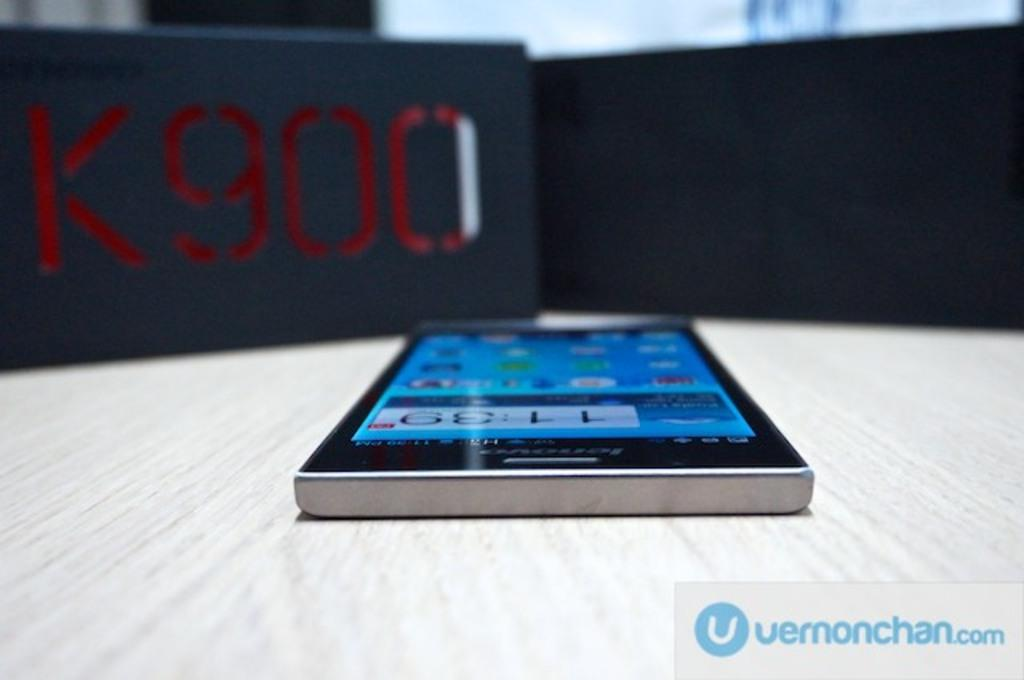<image>
Give a short and clear explanation of the subsequent image. A cell phone is on a table in front for a sign that says K900. 